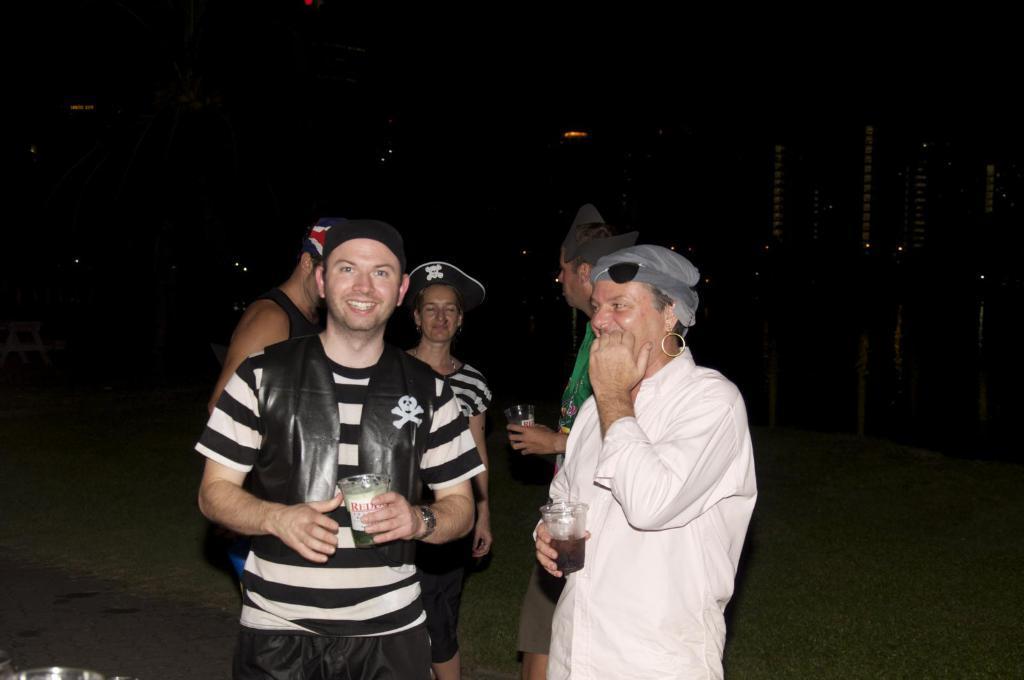Please provide a concise description of this image. There are many people. They are wearing caps. In the background it is dark. 